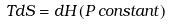<formula> <loc_0><loc_0><loc_500><loc_500>T d S = d H \, ( P \, { c o n s t a n t ) }</formula> 